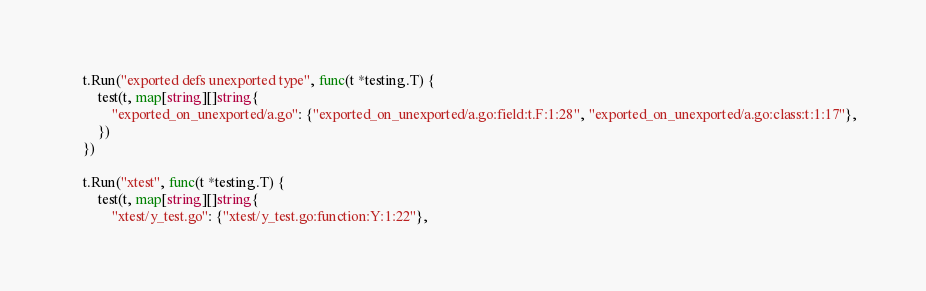Convert code to text. <code><loc_0><loc_0><loc_500><loc_500><_Go_>
	t.Run("exported defs unexported type", func(t *testing.T) {
		test(t, map[string][]string{
			"exported_on_unexported/a.go": {"exported_on_unexported/a.go:field:t.F:1:28", "exported_on_unexported/a.go:class:t:1:17"},
		})
	})

	t.Run("xtest", func(t *testing.T) {
		test(t, map[string][]string{
			"xtest/y_test.go": {"xtest/y_test.go:function:Y:1:22"},</code> 